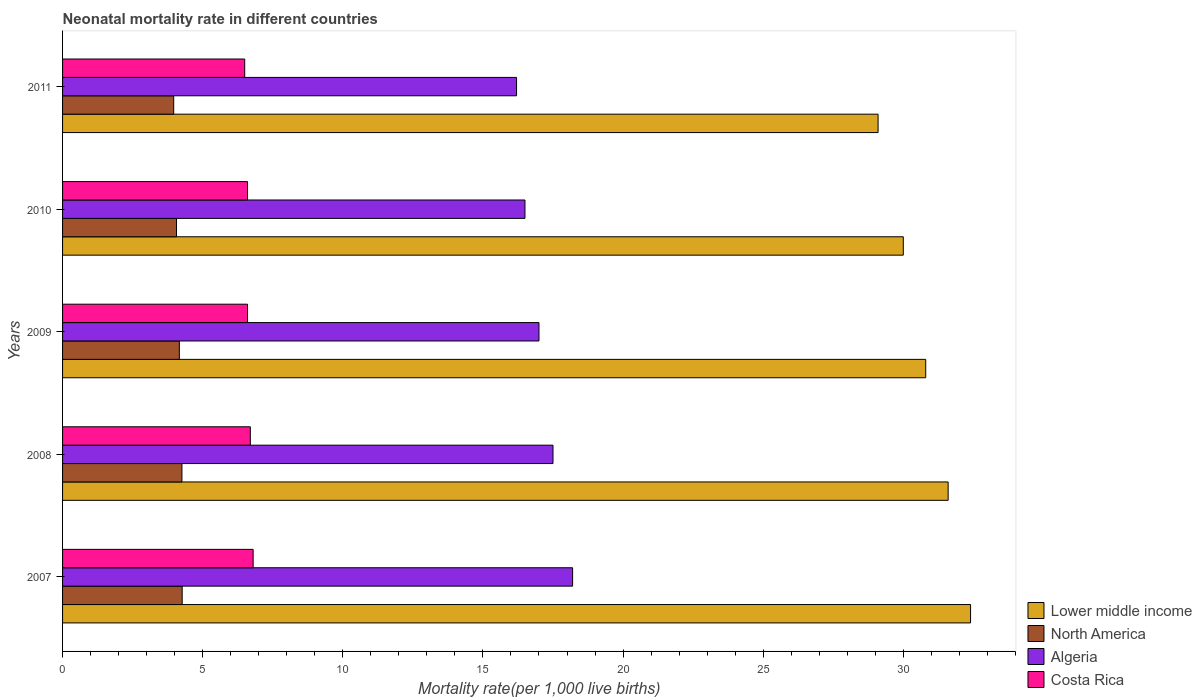How many groups of bars are there?
Provide a succinct answer. 5. Are the number of bars per tick equal to the number of legend labels?
Your answer should be compact. Yes. What is the label of the 2nd group of bars from the top?
Provide a succinct answer. 2010. What is the neonatal mortality rate in North America in 2009?
Make the answer very short. 4.17. Across all years, what is the maximum neonatal mortality rate in Lower middle income?
Offer a very short reply. 32.4. Across all years, what is the minimum neonatal mortality rate in North America?
Your response must be concise. 3.97. In which year was the neonatal mortality rate in Algeria maximum?
Offer a very short reply. 2007. What is the total neonatal mortality rate in Algeria in the graph?
Offer a very short reply. 85.4. What is the difference between the neonatal mortality rate in Algeria in 2008 and that in 2010?
Provide a succinct answer. 1. What is the difference between the neonatal mortality rate in Lower middle income in 2011 and the neonatal mortality rate in North America in 2008?
Your answer should be very brief. 24.84. What is the average neonatal mortality rate in Costa Rica per year?
Make the answer very short. 6.64. In the year 2007, what is the difference between the neonatal mortality rate in North America and neonatal mortality rate in Algeria?
Ensure brevity in your answer.  -13.93. In how many years, is the neonatal mortality rate in Algeria greater than 10 ?
Give a very brief answer. 5. What is the ratio of the neonatal mortality rate in North America in 2007 to that in 2008?
Your answer should be very brief. 1. Is the neonatal mortality rate in North America in 2009 less than that in 2011?
Make the answer very short. No. What is the difference between the highest and the second highest neonatal mortality rate in North America?
Your answer should be very brief. 0.01. In how many years, is the neonatal mortality rate in Costa Rica greater than the average neonatal mortality rate in Costa Rica taken over all years?
Offer a very short reply. 2. Is the sum of the neonatal mortality rate in Algeria in 2008 and 2009 greater than the maximum neonatal mortality rate in Costa Rica across all years?
Offer a terse response. Yes. What does the 2nd bar from the top in 2009 represents?
Give a very brief answer. Algeria. What does the 1st bar from the bottom in 2011 represents?
Keep it short and to the point. Lower middle income. Is it the case that in every year, the sum of the neonatal mortality rate in North America and neonatal mortality rate in Algeria is greater than the neonatal mortality rate in Costa Rica?
Provide a short and direct response. Yes. How many bars are there?
Your answer should be very brief. 20. How many years are there in the graph?
Offer a very short reply. 5. Does the graph contain any zero values?
Your response must be concise. No. How many legend labels are there?
Make the answer very short. 4. How are the legend labels stacked?
Your answer should be very brief. Vertical. What is the title of the graph?
Keep it short and to the point. Neonatal mortality rate in different countries. What is the label or title of the X-axis?
Your answer should be very brief. Mortality rate(per 1,0 live births). What is the Mortality rate(per 1,000 live births) in Lower middle income in 2007?
Offer a very short reply. 32.4. What is the Mortality rate(per 1,000 live births) in North America in 2007?
Offer a very short reply. 4.27. What is the Mortality rate(per 1,000 live births) of Lower middle income in 2008?
Provide a succinct answer. 31.6. What is the Mortality rate(per 1,000 live births) in North America in 2008?
Give a very brief answer. 4.26. What is the Mortality rate(per 1,000 live births) in Lower middle income in 2009?
Make the answer very short. 30.8. What is the Mortality rate(per 1,000 live births) of North America in 2009?
Make the answer very short. 4.17. What is the Mortality rate(per 1,000 live births) in Algeria in 2009?
Offer a very short reply. 17. What is the Mortality rate(per 1,000 live births) of Costa Rica in 2009?
Give a very brief answer. 6.6. What is the Mortality rate(per 1,000 live births) in North America in 2010?
Your answer should be very brief. 4.07. What is the Mortality rate(per 1,000 live births) of Costa Rica in 2010?
Ensure brevity in your answer.  6.6. What is the Mortality rate(per 1,000 live births) of Lower middle income in 2011?
Offer a very short reply. 29.1. What is the Mortality rate(per 1,000 live births) in North America in 2011?
Your answer should be very brief. 3.97. Across all years, what is the maximum Mortality rate(per 1,000 live births) of Lower middle income?
Ensure brevity in your answer.  32.4. Across all years, what is the maximum Mortality rate(per 1,000 live births) of North America?
Ensure brevity in your answer.  4.27. Across all years, what is the maximum Mortality rate(per 1,000 live births) in Algeria?
Your answer should be compact. 18.2. Across all years, what is the minimum Mortality rate(per 1,000 live births) in Lower middle income?
Keep it short and to the point. 29.1. Across all years, what is the minimum Mortality rate(per 1,000 live births) in North America?
Your answer should be compact. 3.97. Across all years, what is the minimum Mortality rate(per 1,000 live births) of Algeria?
Offer a very short reply. 16.2. What is the total Mortality rate(per 1,000 live births) in Lower middle income in the graph?
Provide a succinct answer. 153.9. What is the total Mortality rate(per 1,000 live births) in North America in the graph?
Offer a very short reply. 20.73. What is the total Mortality rate(per 1,000 live births) of Algeria in the graph?
Provide a succinct answer. 85.4. What is the total Mortality rate(per 1,000 live births) of Costa Rica in the graph?
Your response must be concise. 33.2. What is the difference between the Mortality rate(per 1,000 live births) in North America in 2007 and that in 2008?
Give a very brief answer. 0.01. What is the difference between the Mortality rate(per 1,000 live births) in Algeria in 2007 and that in 2008?
Provide a short and direct response. 0.7. What is the difference between the Mortality rate(per 1,000 live births) in Costa Rica in 2007 and that in 2008?
Provide a succinct answer. 0.1. What is the difference between the Mortality rate(per 1,000 live births) in Lower middle income in 2007 and that in 2009?
Keep it short and to the point. 1.6. What is the difference between the Mortality rate(per 1,000 live births) in North America in 2007 and that in 2009?
Provide a short and direct response. 0.1. What is the difference between the Mortality rate(per 1,000 live births) in North America in 2007 and that in 2010?
Make the answer very short. 0.2. What is the difference between the Mortality rate(per 1,000 live births) of Costa Rica in 2007 and that in 2010?
Provide a succinct answer. 0.2. What is the difference between the Mortality rate(per 1,000 live births) in Lower middle income in 2007 and that in 2011?
Make the answer very short. 3.3. What is the difference between the Mortality rate(per 1,000 live births) of North America in 2007 and that in 2011?
Give a very brief answer. 0.3. What is the difference between the Mortality rate(per 1,000 live births) of Lower middle income in 2008 and that in 2009?
Give a very brief answer. 0.8. What is the difference between the Mortality rate(per 1,000 live births) in North America in 2008 and that in 2009?
Ensure brevity in your answer.  0.09. What is the difference between the Mortality rate(per 1,000 live births) in Lower middle income in 2008 and that in 2010?
Offer a very short reply. 1.6. What is the difference between the Mortality rate(per 1,000 live births) of North America in 2008 and that in 2010?
Your response must be concise. 0.19. What is the difference between the Mortality rate(per 1,000 live births) in Lower middle income in 2008 and that in 2011?
Your response must be concise. 2.5. What is the difference between the Mortality rate(per 1,000 live births) in North America in 2008 and that in 2011?
Keep it short and to the point. 0.29. What is the difference between the Mortality rate(per 1,000 live births) in Algeria in 2008 and that in 2011?
Make the answer very short. 1.3. What is the difference between the Mortality rate(per 1,000 live births) in Costa Rica in 2008 and that in 2011?
Give a very brief answer. 0.2. What is the difference between the Mortality rate(per 1,000 live births) of Lower middle income in 2009 and that in 2010?
Ensure brevity in your answer.  0.8. What is the difference between the Mortality rate(per 1,000 live births) in North America in 2009 and that in 2010?
Make the answer very short. 0.1. What is the difference between the Mortality rate(per 1,000 live births) in North America in 2009 and that in 2011?
Offer a terse response. 0.2. What is the difference between the Mortality rate(per 1,000 live births) in Algeria in 2009 and that in 2011?
Your answer should be compact. 0.8. What is the difference between the Mortality rate(per 1,000 live births) of Costa Rica in 2009 and that in 2011?
Give a very brief answer. 0.1. What is the difference between the Mortality rate(per 1,000 live births) in Lower middle income in 2010 and that in 2011?
Make the answer very short. 0.9. What is the difference between the Mortality rate(per 1,000 live births) of North America in 2010 and that in 2011?
Your response must be concise. 0.1. What is the difference between the Mortality rate(per 1,000 live births) of Costa Rica in 2010 and that in 2011?
Provide a succinct answer. 0.1. What is the difference between the Mortality rate(per 1,000 live births) in Lower middle income in 2007 and the Mortality rate(per 1,000 live births) in North America in 2008?
Give a very brief answer. 28.14. What is the difference between the Mortality rate(per 1,000 live births) of Lower middle income in 2007 and the Mortality rate(per 1,000 live births) of Costa Rica in 2008?
Your answer should be compact. 25.7. What is the difference between the Mortality rate(per 1,000 live births) of North America in 2007 and the Mortality rate(per 1,000 live births) of Algeria in 2008?
Your answer should be compact. -13.23. What is the difference between the Mortality rate(per 1,000 live births) of North America in 2007 and the Mortality rate(per 1,000 live births) of Costa Rica in 2008?
Make the answer very short. -2.43. What is the difference between the Mortality rate(per 1,000 live births) of Lower middle income in 2007 and the Mortality rate(per 1,000 live births) of North America in 2009?
Keep it short and to the point. 28.23. What is the difference between the Mortality rate(per 1,000 live births) in Lower middle income in 2007 and the Mortality rate(per 1,000 live births) in Costa Rica in 2009?
Give a very brief answer. 25.8. What is the difference between the Mortality rate(per 1,000 live births) of North America in 2007 and the Mortality rate(per 1,000 live births) of Algeria in 2009?
Your response must be concise. -12.73. What is the difference between the Mortality rate(per 1,000 live births) of North America in 2007 and the Mortality rate(per 1,000 live births) of Costa Rica in 2009?
Your response must be concise. -2.33. What is the difference between the Mortality rate(per 1,000 live births) in Lower middle income in 2007 and the Mortality rate(per 1,000 live births) in North America in 2010?
Offer a terse response. 28.33. What is the difference between the Mortality rate(per 1,000 live births) of Lower middle income in 2007 and the Mortality rate(per 1,000 live births) of Algeria in 2010?
Offer a terse response. 15.9. What is the difference between the Mortality rate(per 1,000 live births) of Lower middle income in 2007 and the Mortality rate(per 1,000 live births) of Costa Rica in 2010?
Offer a terse response. 25.8. What is the difference between the Mortality rate(per 1,000 live births) of North America in 2007 and the Mortality rate(per 1,000 live births) of Algeria in 2010?
Ensure brevity in your answer.  -12.23. What is the difference between the Mortality rate(per 1,000 live births) in North America in 2007 and the Mortality rate(per 1,000 live births) in Costa Rica in 2010?
Keep it short and to the point. -2.33. What is the difference between the Mortality rate(per 1,000 live births) in Lower middle income in 2007 and the Mortality rate(per 1,000 live births) in North America in 2011?
Provide a short and direct response. 28.43. What is the difference between the Mortality rate(per 1,000 live births) of Lower middle income in 2007 and the Mortality rate(per 1,000 live births) of Costa Rica in 2011?
Provide a short and direct response. 25.9. What is the difference between the Mortality rate(per 1,000 live births) of North America in 2007 and the Mortality rate(per 1,000 live births) of Algeria in 2011?
Ensure brevity in your answer.  -11.93. What is the difference between the Mortality rate(per 1,000 live births) in North America in 2007 and the Mortality rate(per 1,000 live births) in Costa Rica in 2011?
Provide a succinct answer. -2.23. What is the difference between the Mortality rate(per 1,000 live births) in Lower middle income in 2008 and the Mortality rate(per 1,000 live births) in North America in 2009?
Your answer should be very brief. 27.43. What is the difference between the Mortality rate(per 1,000 live births) of Lower middle income in 2008 and the Mortality rate(per 1,000 live births) of Costa Rica in 2009?
Make the answer very short. 25. What is the difference between the Mortality rate(per 1,000 live births) of North America in 2008 and the Mortality rate(per 1,000 live births) of Algeria in 2009?
Keep it short and to the point. -12.74. What is the difference between the Mortality rate(per 1,000 live births) of North America in 2008 and the Mortality rate(per 1,000 live births) of Costa Rica in 2009?
Make the answer very short. -2.34. What is the difference between the Mortality rate(per 1,000 live births) of Algeria in 2008 and the Mortality rate(per 1,000 live births) of Costa Rica in 2009?
Offer a terse response. 10.9. What is the difference between the Mortality rate(per 1,000 live births) in Lower middle income in 2008 and the Mortality rate(per 1,000 live births) in North America in 2010?
Offer a very short reply. 27.53. What is the difference between the Mortality rate(per 1,000 live births) of Lower middle income in 2008 and the Mortality rate(per 1,000 live births) of Costa Rica in 2010?
Your response must be concise. 25. What is the difference between the Mortality rate(per 1,000 live births) in North America in 2008 and the Mortality rate(per 1,000 live births) in Algeria in 2010?
Offer a terse response. -12.24. What is the difference between the Mortality rate(per 1,000 live births) in North America in 2008 and the Mortality rate(per 1,000 live births) in Costa Rica in 2010?
Offer a very short reply. -2.34. What is the difference between the Mortality rate(per 1,000 live births) in Algeria in 2008 and the Mortality rate(per 1,000 live births) in Costa Rica in 2010?
Your response must be concise. 10.9. What is the difference between the Mortality rate(per 1,000 live births) of Lower middle income in 2008 and the Mortality rate(per 1,000 live births) of North America in 2011?
Ensure brevity in your answer.  27.63. What is the difference between the Mortality rate(per 1,000 live births) in Lower middle income in 2008 and the Mortality rate(per 1,000 live births) in Algeria in 2011?
Keep it short and to the point. 15.4. What is the difference between the Mortality rate(per 1,000 live births) in Lower middle income in 2008 and the Mortality rate(per 1,000 live births) in Costa Rica in 2011?
Offer a terse response. 25.1. What is the difference between the Mortality rate(per 1,000 live births) in North America in 2008 and the Mortality rate(per 1,000 live births) in Algeria in 2011?
Keep it short and to the point. -11.94. What is the difference between the Mortality rate(per 1,000 live births) in North America in 2008 and the Mortality rate(per 1,000 live births) in Costa Rica in 2011?
Make the answer very short. -2.24. What is the difference between the Mortality rate(per 1,000 live births) in Algeria in 2008 and the Mortality rate(per 1,000 live births) in Costa Rica in 2011?
Keep it short and to the point. 11. What is the difference between the Mortality rate(per 1,000 live births) in Lower middle income in 2009 and the Mortality rate(per 1,000 live births) in North America in 2010?
Your answer should be compact. 26.73. What is the difference between the Mortality rate(per 1,000 live births) in Lower middle income in 2009 and the Mortality rate(per 1,000 live births) in Costa Rica in 2010?
Offer a very short reply. 24.2. What is the difference between the Mortality rate(per 1,000 live births) of North America in 2009 and the Mortality rate(per 1,000 live births) of Algeria in 2010?
Your response must be concise. -12.33. What is the difference between the Mortality rate(per 1,000 live births) in North America in 2009 and the Mortality rate(per 1,000 live births) in Costa Rica in 2010?
Provide a succinct answer. -2.43. What is the difference between the Mortality rate(per 1,000 live births) in Algeria in 2009 and the Mortality rate(per 1,000 live births) in Costa Rica in 2010?
Keep it short and to the point. 10.4. What is the difference between the Mortality rate(per 1,000 live births) in Lower middle income in 2009 and the Mortality rate(per 1,000 live births) in North America in 2011?
Your answer should be very brief. 26.83. What is the difference between the Mortality rate(per 1,000 live births) in Lower middle income in 2009 and the Mortality rate(per 1,000 live births) in Algeria in 2011?
Make the answer very short. 14.6. What is the difference between the Mortality rate(per 1,000 live births) in Lower middle income in 2009 and the Mortality rate(per 1,000 live births) in Costa Rica in 2011?
Your response must be concise. 24.3. What is the difference between the Mortality rate(per 1,000 live births) of North America in 2009 and the Mortality rate(per 1,000 live births) of Algeria in 2011?
Provide a succinct answer. -12.03. What is the difference between the Mortality rate(per 1,000 live births) in North America in 2009 and the Mortality rate(per 1,000 live births) in Costa Rica in 2011?
Keep it short and to the point. -2.33. What is the difference between the Mortality rate(per 1,000 live births) of Algeria in 2009 and the Mortality rate(per 1,000 live births) of Costa Rica in 2011?
Offer a very short reply. 10.5. What is the difference between the Mortality rate(per 1,000 live births) in Lower middle income in 2010 and the Mortality rate(per 1,000 live births) in North America in 2011?
Provide a short and direct response. 26.03. What is the difference between the Mortality rate(per 1,000 live births) of Lower middle income in 2010 and the Mortality rate(per 1,000 live births) of Algeria in 2011?
Make the answer very short. 13.8. What is the difference between the Mortality rate(per 1,000 live births) of North America in 2010 and the Mortality rate(per 1,000 live births) of Algeria in 2011?
Offer a very short reply. -12.13. What is the difference between the Mortality rate(per 1,000 live births) in North America in 2010 and the Mortality rate(per 1,000 live births) in Costa Rica in 2011?
Your response must be concise. -2.43. What is the difference between the Mortality rate(per 1,000 live births) of Algeria in 2010 and the Mortality rate(per 1,000 live births) of Costa Rica in 2011?
Provide a succinct answer. 10. What is the average Mortality rate(per 1,000 live births) of Lower middle income per year?
Offer a very short reply. 30.78. What is the average Mortality rate(per 1,000 live births) in North America per year?
Your answer should be compact. 4.15. What is the average Mortality rate(per 1,000 live births) in Algeria per year?
Make the answer very short. 17.08. What is the average Mortality rate(per 1,000 live births) of Costa Rica per year?
Ensure brevity in your answer.  6.64. In the year 2007, what is the difference between the Mortality rate(per 1,000 live births) in Lower middle income and Mortality rate(per 1,000 live births) in North America?
Make the answer very short. 28.13. In the year 2007, what is the difference between the Mortality rate(per 1,000 live births) in Lower middle income and Mortality rate(per 1,000 live births) in Costa Rica?
Give a very brief answer. 25.6. In the year 2007, what is the difference between the Mortality rate(per 1,000 live births) of North America and Mortality rate(per 1,000 live births) of Algeria?
Give a very brief answer. -13.93. In the year 2007, what is the difference between the Mortality rate(per 1,000 live births) in North America and Mortality rate(per 1,000 live births) in Costa Rica?
Provide a short and direct response. -2.53. In the year 2008, what is the difference between the Mortality rate(per 1,000 live births) in Lower middle income and Mortality rate(per 1,000 live births) in North America?
Offer a terse response. 27.34. In the year 2008, what is the difference between the Mortality rate(per 1,000 live births) of Lower middle income and Mortality rate(per 1,000 live births) of Algeria?
Offer a very short reply. 14.1. In the year 2008, what is the difference between the Mortality rate(per 1,000 live births) of Lower middle income and Mortality rate(per 1,000 live births) of Costa Rica?
Provide a short and direct response. 24.9. In the year 2008, what is the difference between the Mortality rate(per 1,000 live births) of North America and Mortality rate(per 1,000 live births) of Algeria?
Your answer should be very brief. -13.24. In the year 2008, what is the difference between the Mortality rate(per 1,000 live births) of North America and Mortality rate(per 1,000 live births) of Costa Rica?
Your answer should be compact. -2.44. In the year 2008, what is the difference between the Mortality rate(per 1,000 live births) of Algeria and Mortality rate(per 1,000 live births) of Costa Rica?
Your response must be concise. 10.8. In the year 2009, what is the difference between the Mortality rate(per 1,000 live births) in Lower middle income and Mortality rate(per 1,000 live births) in North America?
Offer a terse response. 26.63. In the year 2009, what is the difference between the Mortality rate(per 1,000 live births) of Lower middle income and Mortality rate(per 1,000 live births) of Algeria?
Offer a very short reply. 13.8. In the year 2009, what is the difference between the Mortality rate(per 1,000 live births) in Lower middle income and Mortality rate(per 1,000 live births) in Costa Rica?
Your answer should be compact. 24.2. In the year 2009, what is the difference between the Mortality rate(per 1,000 live births) in North America and Mortality rate(per 1,000 live births) in Algeria?
Keep it short and to the point. -12.83. In the year 2009, what is the difference between the Mortality rate(per 1,000 live births) of North America and Mortality rate(per 1,000 live births) of Costa Rica?
Provide a succinct answer. -2.43. In the year 2009, what is the difference between the Mortality rate(per 1,000 live births) in Algeria and Mortality rate(per 1,000 live births) in Costa Rica?
Your answer should be compact. 10.4. In the year 2010, what is the difference between the Mortality rate(per 1,000 live births) of Lower middle income and Mortality rate(per 1,000 live births) of North America?
Your answer should be compact. 25.93. In the year 2010, what is the difference between the Mortality rate(per 1,000 live births) of Lower middle income and Mortality rate(per 1,000 live births) of Costa Rica?
Offer a terse response. 23.4. In the year 2010, what is the difference between the Mortality rate(per 1,000 live births) of North America and Mortality rate(per 1,000 live births) of Algeria?
Provide a short and direct response. -12.43. In the year 2010, what is the difference between the Mortality rate(per 1,000 live births) of North America and Mortality rate(per 1,000 live births) of Costa Rica?
Make the answer very short. -2.53. In the year 2010, what is the difference between the Mortality rate(per 1,000 live births) in Algeria and Mortality rate(per 1,000 live births) in Costa Rica?
Offer a terse response. 9.9. In the year 2011, what is the difference between the Mortality rate(per 1,000 live births) in Lower middle income and Mortality rate(per 1,000 live births) in North America?
Offer a very short reply. 25.13. In the year 2011, what is the difference between the Mortality rate(per 1,000 live births) in Lower middle income and Mortality rate(per 1,000 live births) in Algeria?
Give a very brief answer. 12.9. In the year 2011, what is the difference between the Mortality rate(per 1,000 live births) of Lower middle income and Mortality rate(per 1,000 live births) of Costa Rica?
Your response must be concise. 22.6. In the year 2011, what is the difference between the Mortality rate(per 1,000 live births) of North America and Mortality rate(per 1,000 live births) of Algeria?
Your answer should be very brief. -12.23. In the year 2011, what is the difference between the Mortality rate(per 1,000 live births) of North America and Mortality rate(per 1,000 live births) of Costa Rica?
Make the answer very short. -2.53. What is the ratio of the Mortality rate(per 1,000 live births) in Lower middle income in 2007 to that in 2008?
Offer a terse response. 1.03. What is the ratio of the Mortality rate(per 1,000 live births) in North America in 2007 to that in 2008?
Offer a terse response. 1. What is the ratio of the Mortality rate(per 1,000 live births) of Costa Rica in 2007 to that in 2008?
Make the answer very short. 1.01. What is the ratio of the Mortality rate(per 1,000 live births) of Lower middle income in 2007 to that in 2009?
Keep it short and to the point. 1.05. What is the ratio of the Mortality rate(per 1,000 live births) in North America in 2007 to that in 2009?
Keep it short and to the point. 1.02. What is the ratio of the Mortality rate(per 1,000 live births) of Algeria in 2007 to that in 2009?
Provide a short and direct response. 1.07. What is the ratio of the Mortality rate(per 1,000 live births) of Costa Rica in 2007 to that in 2009?
Ensure brevity in your answer.  1.03. What is the ratio of the Mortality rate(per 1,000 live births) in North America in 2007 to that in 2010?
Ensure brevity in your answer.  1.05. What is the ratio of the Mortality rate(per 1,000 live births) of Algeria in 2007 to that in 2010?
Keep it short and to the point. 1.1. What is the ratio of the Mortality rate(per 1,000 live births) in Costa Rica in 2007 to that in 2010?
Provide a succinct answer. 1.03. What is the ratio of the Mortality rate(per 1,000 live births) of Lower middle income in 2007 to that in 2011?
Provide a succinct answer. 1.11. What is the ratio of the Mortality rate(per 1,000 live births) of North America in 2007 to that in 2011?
Provide a succinct answer. 1.08. What is the ratio of the Mortality rate(per 1,000 live births) in Algeria in 2007 to that in 2011?
Make the answer very short. 1.12. What is the ratio of the Mortality rate(per 1,000 live births) in Costa Rica in 2007 to that in 2011?
Ensure brevity in your answer.  1.05. What is the ratio of the Mortality rate(per 1,000 live births) of Lower middle income in 2008 to that in 2009?
Give a very brief answer. 1.03. What is the ratio of the Mortality rate(per 1,000 live births) of North America in 2008 to that in 2009?
Your answer should be very brief. 1.02. What is the ratio of the Mortality rate(per 1,000 live births) of Algeria in 2008 to that in 2009?
Provide a succinct answer. 1.03. What is the ratio of the Mortality rate(per 1,000 live births) of Costa Rica in 2008 to that in 2009?
Ensure brevity in your answer.  1.02. What is the ratio of the Mortality rate(per 1,000 live births) in Lower middle income in 2008 to that in 2010?
Provide a succinct answer. 1.05. What is the ratio of the Mortality rate(per 1,000 live births) of North America in 2008 to that in 2010?
Offer a very short reply. 1.05. What is the ratio of the Mortality rate(per 1,000 live births) in Algeria in 2008 to that in 2010?
Provide a succinct answer. 1.06. What is the ratio of the Mortality rate(per 1,000 live births) in Costa Rica in 2008 to that in 2010?
Give a very brief answer. 1.02. What is the ratio of the Mortality rate(per 1,000 live births) of Lower middle income in 2008 to that in 2011?
Your answer should be very brief. 1.09. What is the ratio of the Mortality rate(per 1,000 live births) in North America in 2008 to that in 2011?
Provide a short and direct response. 1.07. What is the ratio of the Mortality rate(per 1,000 live births) of Algeria in 2008 to that in 2011?
Give a very brief answer. 1.08. What is the ratio of the Mortality rate(per 1,000 live births) of Costa Rica in 2008 to that in 2011?
Offer a very short reply. 1.03. What is the ratio of the Mortality rate(per 1,000 live births) in Lower middle income in 2009 to that in 2010?
Ensure brevity in your answer.  1.03. What is the ratio of the Mortality rate(per 1,000 live births) in North America in 2009 to that in 2010?
Provide a short and direct response. 1.02. What is the ratio of the Mortality rate(per 1,000 live births) in Algeria in 2009 to that in 2010?
Offer a very short reply. 1.03. What is the ratio of the Mortality rate(per 1,000 live births) in Costa Rica in 2009 to that in 2010?
Ensure brevity in your answer.  1. What is the ratio of the Mortality rate(per 1,000 live births) of Lower middle income in 2009 to that in 2011?
Ensure brevity in your answer.  1.06. What is the ratio of the Mortality rate(per 1,000 live births) in North America in 2009 to that in 2011?
Make the answer very short. 1.05. What is the ratio of the Mortality rate(per 1,000 live births) of Algeria in 2009 to that in 2011?
Offer a very short reply. 1.05. What is the ratio of the Mortality rate(per 1,000 live births) of Costa Rica in 2009 to that in 2011?
Your answer should be compact. 1.02. What is the ratio of the Mortality rate(per 1,000 live births) of Lower middle income in 2010 to that in 2011?
Provide a short and direct response. 1.03. What is the ratio of the Mortality rate(per 1,000 live births) of North America in 2010 to that in 2011?
Your response must be concise. 1.03. What is the ratio of the Mortality rate(per 1,000 live births) of Algeria in 2010 to that in 2011?
Your answer should be very brief. 1.02. What is the ratio of the Mortality rate(per 1,000 live births) of Costa Rica in 2010 to that in 2011?
Offer a terse response. 1.02. What is the difference between the highest and the second highest Mortality rate(per 1,000 live births) of North America?
Provide a succinct answer. 0.01. What is the difference between the highest and the second highest Mortality rate(per 1,000 live births) of Algeria?
Offer a terse response. 0.7. What is the difference between the highest and the second highest Mortality rate(per 1,000 live births) of Costa Rica?
Provide a succinct answer. 0.1. What is the difference between the highest and the lowest Mortality rate(per 1,000 live births) in North America?
Offer a terse response. 0.3. What is the difference between the highest and the lowest Mortality rate(per 1,000 live births) in Costa Rica?
Provide a succinct answer. 0.3. 